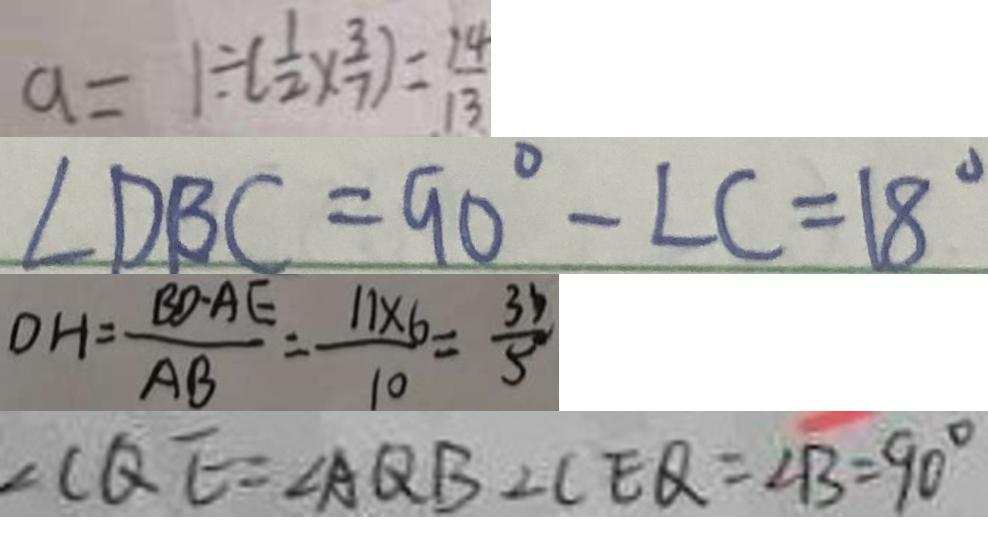Convert formula to latex. <formula><loc_0><loc_0><loc_500><loc_500>a = 1 \div ( \frac { 1 } { 2 } \times \frac { 3 } { 7 } ) = \frac { 1 4 } { 1 3 } 
 \angle D B C = 9 0 ^ { \circ } - \angle C = 1 8 ^ { \circ } 
 D H = \frac { B D \cdot A E } { A B } = \frac { 1 1 \times 6 } { 1 0 } = \frac { 3 3 } { 5 } 
 \angle C Q E = \angle A Q B \bot C E Q = \angle B = 9 0 ^ { \circ }</formula> 